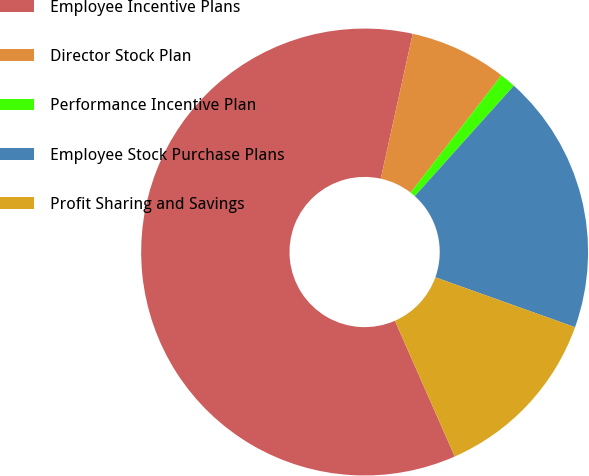<chart> <loc_0><loc_0><loc_500><loc_500><pie_chart><fcel>Employee Incentive Plans<fcel>Director Stock Plan<fcel>Performance Incentive Plan<fcel>Employee Stock Purchase Plans<fcel>Profit Sharing and Savings<nl><fcel>60.06%<fcel>7.04%<fcel>1.15%<fcel>18.82%<fcel>12.93%<nl></chart> 